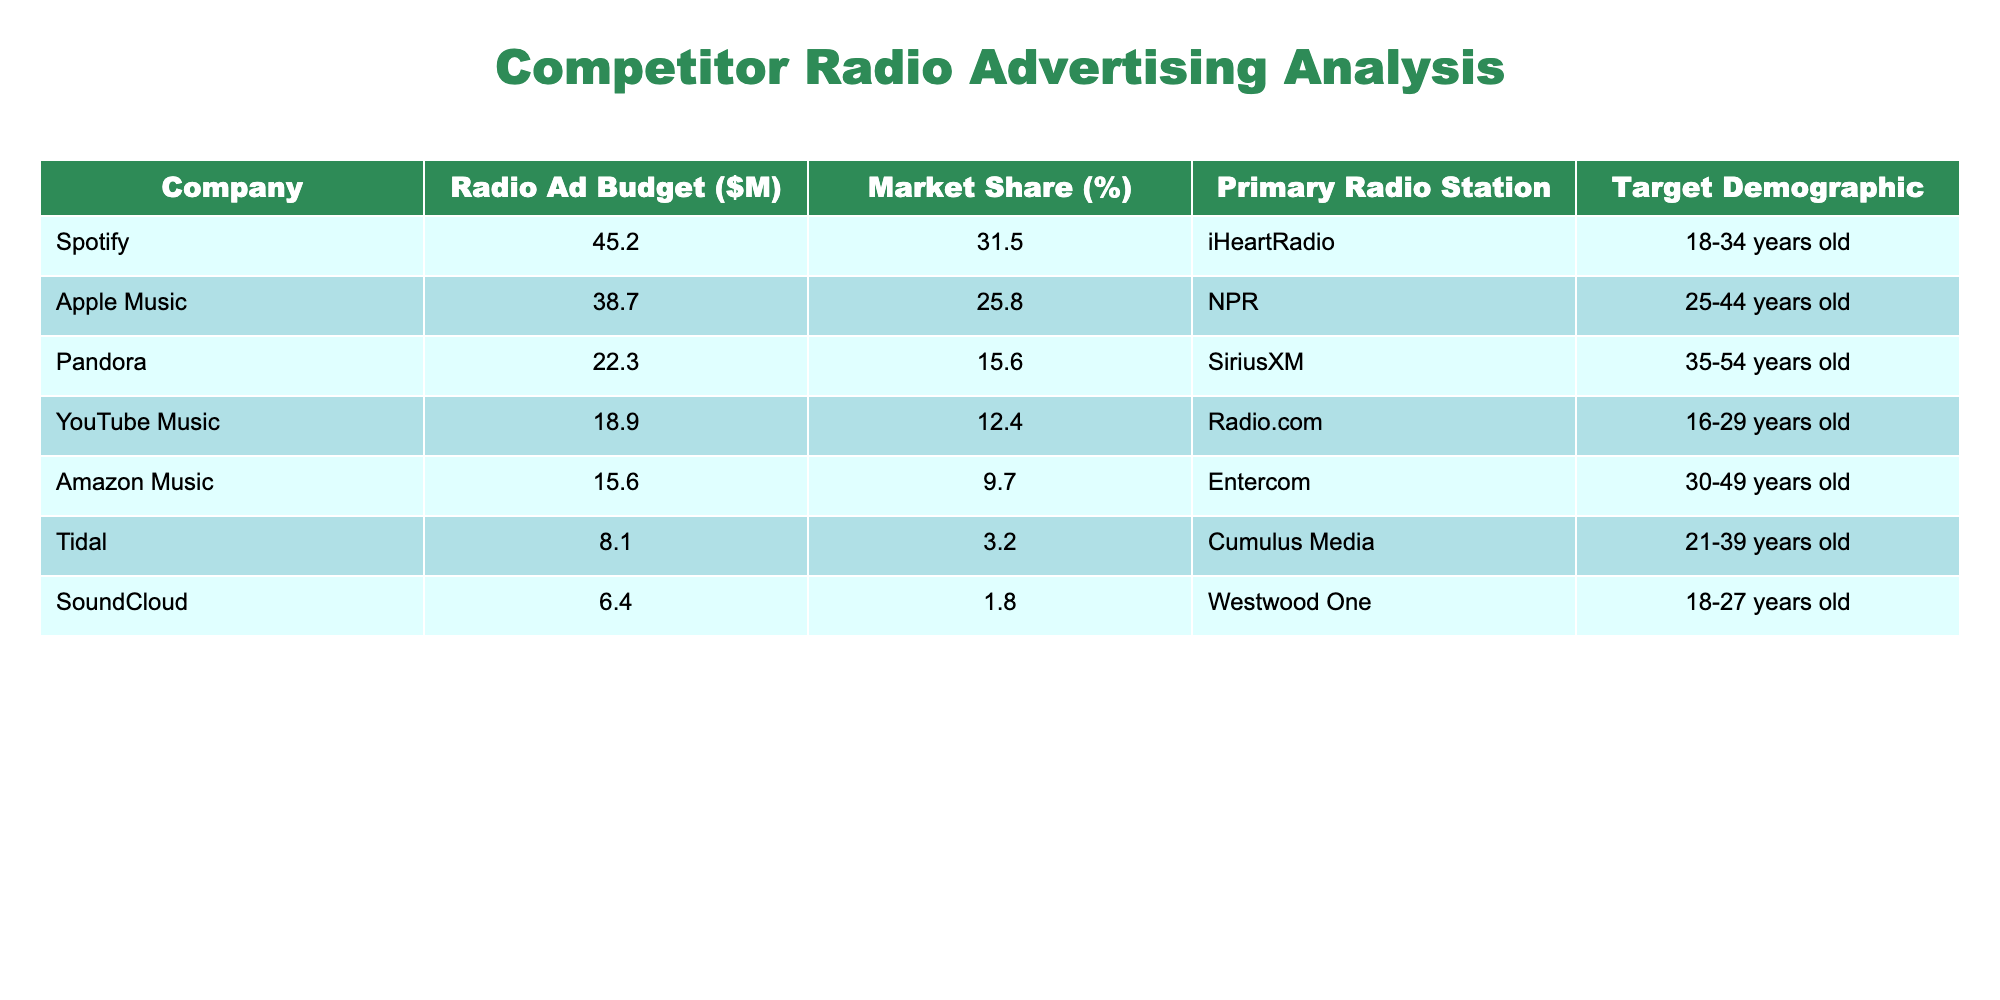What is the radio ad budget of Spotify? The table lists Spotify's radio ad budget as $45.2 million.
Answer: $45.2 million Which company has the highest market share? By comparing the market share percentages in the table, Spotify has the highest market share at 31.5%.
Answer: Spotify What is the total radio ad budget for Apple Music and Amazon Music combined? Adding Apple Music's budget ($38.7 million) and Amazon Music's budget ($15.6 million) gives $38.7 + $15.6 = $54.3 million.
Answer: $54.3 million Is the primary radio station for Tidal Cumulus Media? According to the table, the primary radio station for Tidal is indeed Cumulus Media.
Answer: Yes What is the average market share of all companies listed? The sum of the market shares (31.5 + 25.8 + 15.6 + 12.4 + 9.7 + 3.2 + 1.8) equals 99.0%. Dividing by 7 gives an average of 99.0 / 7 ≈ 14.14%.
Answer: Approximately 14.14% Which company has the lowest radio ad budget, and what is that amount? By examining the table, SoundCloud has the lowest radio ad budget at $6.4 million.
Answer: $6.4 million What total percentage of market share do Pandora and YouTube Music hold together? Adding the market shares of Pandora (15.6%) and YouTube Music (12.4%) gives 15.6 + 12.4 = 28.0%.
Answer: 28.0% Can you infer if the company with the largest budget has the largest market share? Yes, because Spotify has both the largest radio ad budget and the largest market share among the listed companies.
Answer: Yes What is the difference in market share between Apple Music and Amazon Music? The market share for Apple Music is 25.8% and for Amazon Music is 9.7%. The difference is 25.8 - 9.7 = 16.1%.
Answer: 16.1% Which demographic does YouTube Music primarily target? The table shows that YouTube Music primarily targets the 16-29 years old demographic.
Answer: 16-29 years old 